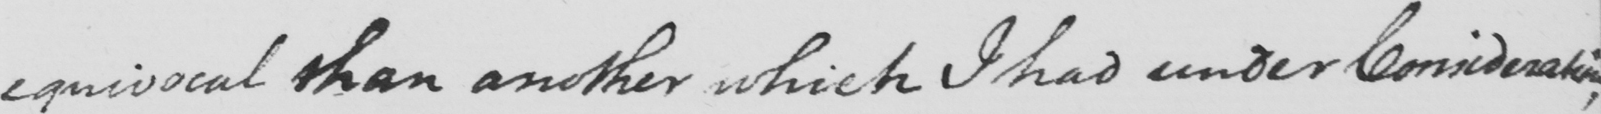Can you read and transcribe this handwriting? equivocal than another which I had under Consideration ; 